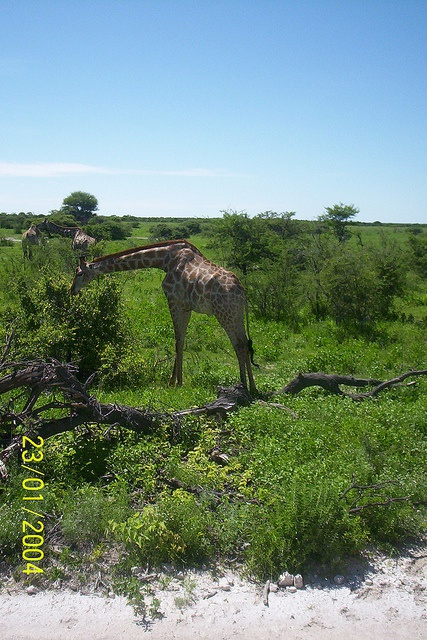Describe the objects in this image and their specific colors. I can see giraffe in lightblue, black, darkgreen, and gray tones and giraffe in lightblue, black, gray, and darkgreen tones in this image. 